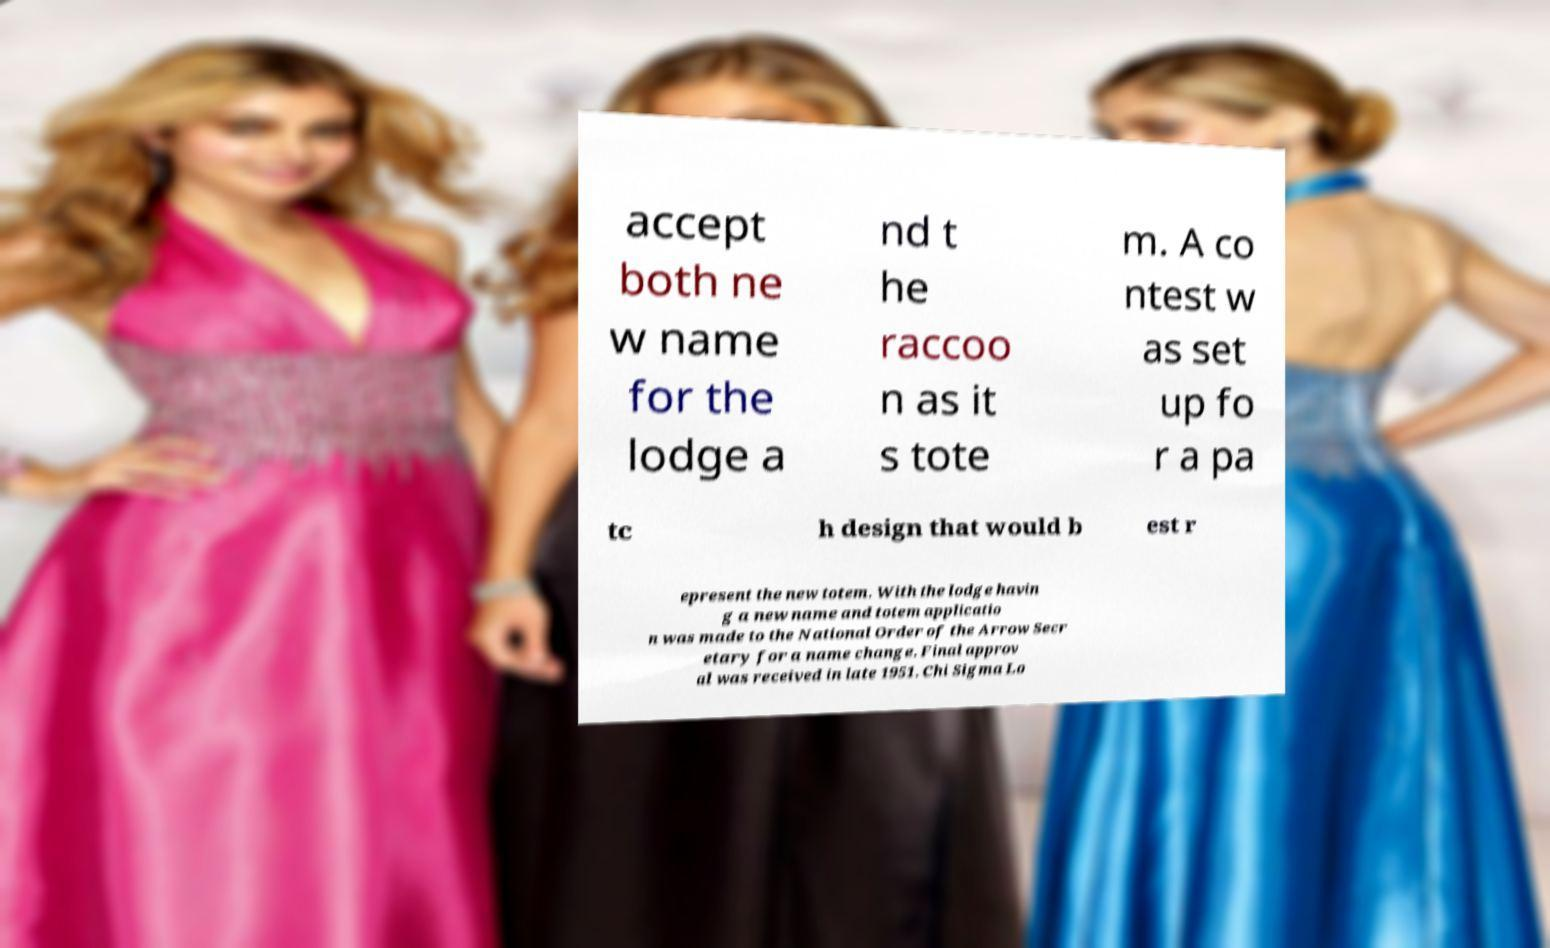For documentation purposes, I need the text within this image transcribed. Could you provide that? accept both ne w name for the lodge a nd t he raccoo n as it s tote m. A co ntest w as set up fo r a pa tc h design that would b est r epresent the new totem. With the lodge havin g a new name and totem applicatio n was made to the National Order of the Arrow Secr etary for a name change. Final approv al was received in late 1951. Chi Sigma Lo 